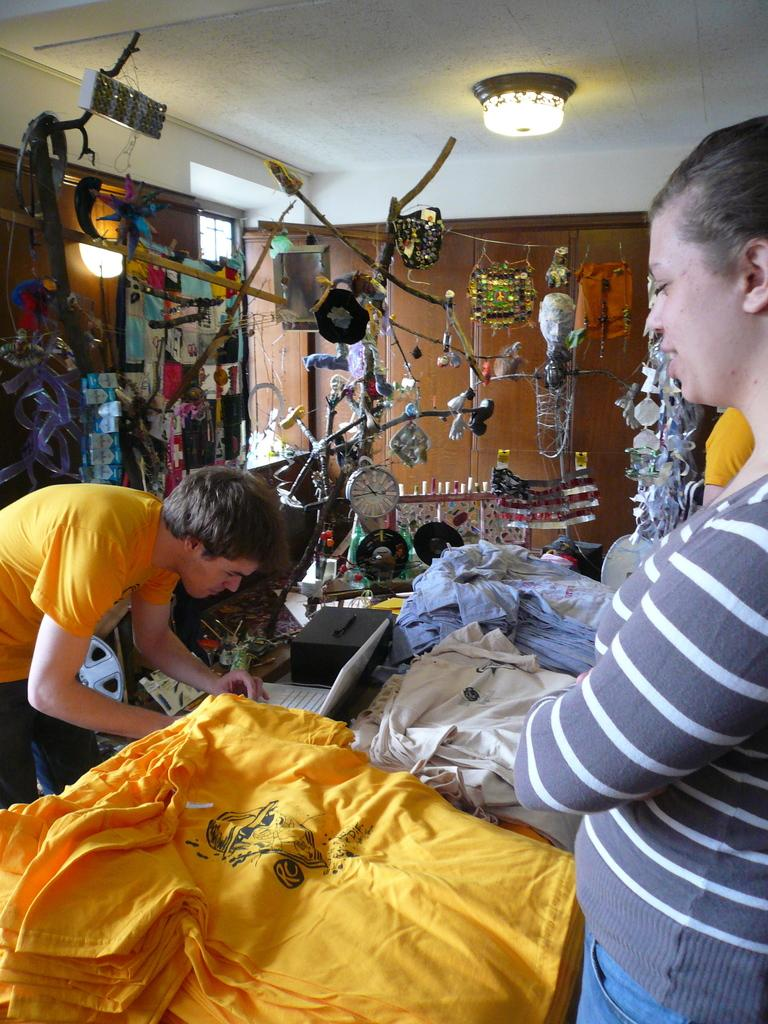What can be seen in the image involving people? There are people standing in the image. What are the people wearing? The people are wearing clothes. What time-related object is visible in the image? There is a clock visible in the image. What type of illumination is present in the image? There is a light in the image. What additional decorative elements can be seen in the image? There are decorative things in the image. What type of door is present in the image? There is a wooden door in the image. What type of approval is being given in the image? There is no indication of approval being given in the image. 